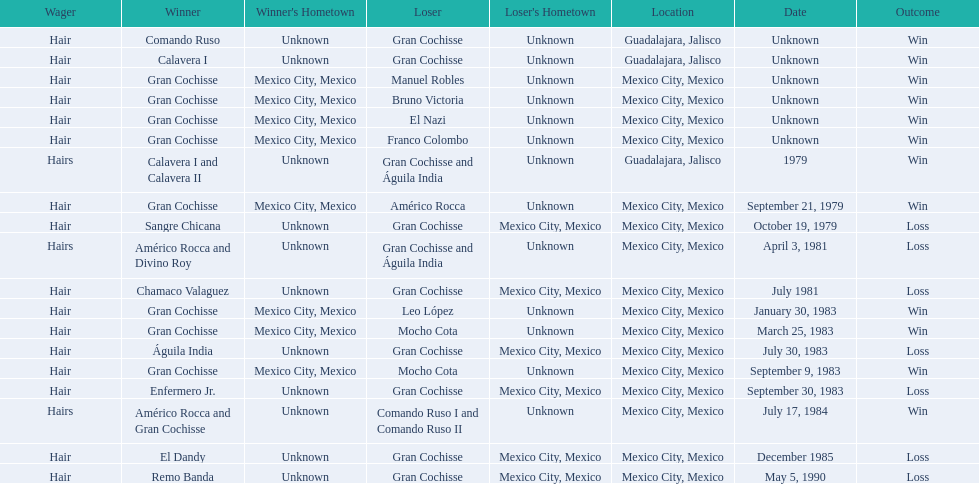How many times has gran cochisse been a winner? 9. Would you be able to parse every entry in this table? {'header': ['Wager', 'Winner', "Winner's Hometown", 'Loser', "Loser's Hometown", 'Location', 'Date', 'Outcome'], 'rows': [['Hair', 'Comando Ruso', 'Unknown', 'Gran Cochisse', 'Unknown', 'Guadalajara, Jalisco', 'Unknown', 'Win'], ['Hair', 'Calavera I', 'Unknown', 'Gran Cochisse', 'Unknown', 'Guadalajara, Jalisco', 'Unknown', 'Win'], ['Hair', 'Gran Cochisse', 'Mexico City, Mexico', 'Manuel Robles', 'Unknown', 'Mexico City, Mexico', 'Unknown', 'Win'], ['Hair', 'Gran Cochisse', 'Mexico City, Mexico', 'Bruno Victoria', 'Unknown', 'Mexico City, Mexico', 'Unknown', 'Win'], ['Hair', 'Gran Cochisse', 'Mexico City, Mexico', 'El Nazi', 'Unknown', 'Mexico City, Mexico', 'Unknown', 'Win'], ['Hair', 'Gran Cochisse', 'Mexico City, Mexico', 'Franco Colombo', 'Unknown', 'Mexico City, Mexico', 'Unknown', 'Win'], ['Hairs', 'Calavera I and Calavera II', 'Unknown', 'Gran Cochisse and Águila India', 'Unknown', 'Guadalajara, Jalisco', '1979', 'Win'], ['Hair', 'Gran Cochisse', 'Mexico City, Mexico', 'Américo Rocca', 'Unknown', 'Mexico City, Mexico', 'September 21, 1979', 'Win'], ['Hair', 'Sangre Chicana', 'Unknown', 'Gran Cochisse', 'Mexico City, Mexico', 'Mexico City, Mexico', 'October 19, 1979', 'Loss'], ['Hairs', 'Américo Rocca and Divino Roy', 'Unknown', 'Gran Cochisse and Águila India', 'Unknown', 'Mexico City, Mexico', 'April 3, 1981', 'Loss'], ['Hair', 'Chamaco Valaguez', 'Unknown', 'Gran Cochisse', 'Mexico City, Mexico', 'Mexico City, Mexico', 'July 1981', 'Loss'], ['Hair', 'Gran Cochisse', 'Mexico City, Mexico', 'Leo López', 'Unknown', 'Mexico City, Mexico', 'January 30, 1983', 'Win'], ['Hair', 'Gran Cochisse', 'Mexico City, Mexico', 'Mocho Cota', 'Unknown', 'Mexico City, Mexico', 'March 25, 1983', 'Win'], ['Hair', 'Águila India', 'Unknown', 'Gran Cochisse', 'Mexico City, Mexico', 'Mexico City, Mexico', 'July 30, 1983', 'Loss'], ['Hair', 'Gran Cochisse', 'Mexico City, Mexico', 'Mocho Cota', 'Unknown', 'Mexico City, Mexico', 'September 9, 1983', 'Win'], ['Hair', 'Enfermero Jr.', 'Unknown', 'Gran Cochisse', 'Mexico City, Mexico', 'Mexico City, Mexico', 'September 30, 1983', 'Loss'], ['Hairs', 'Américo Rocca and Gran Cochisse', 'Unknown', 'Comando Ruso I and Comando Ruso II', 'Unknown', 'Mexico City, Mexico', 'July 17, 1984', 'Win'], ['Hair', 'El Dandy', 'Unknown', 'Gran Cochisse', 'Mexico City, Mexico', 'Mexico City, Mexico', 'December 1985', 'Loss'], ['Hair', 'Remo Banda', 'Unknown', 'Gran Cochisse', 'Mexico City, Mexico', 'Mexico City, Mexico', 'May 5, 1990', 'Loss']]} 